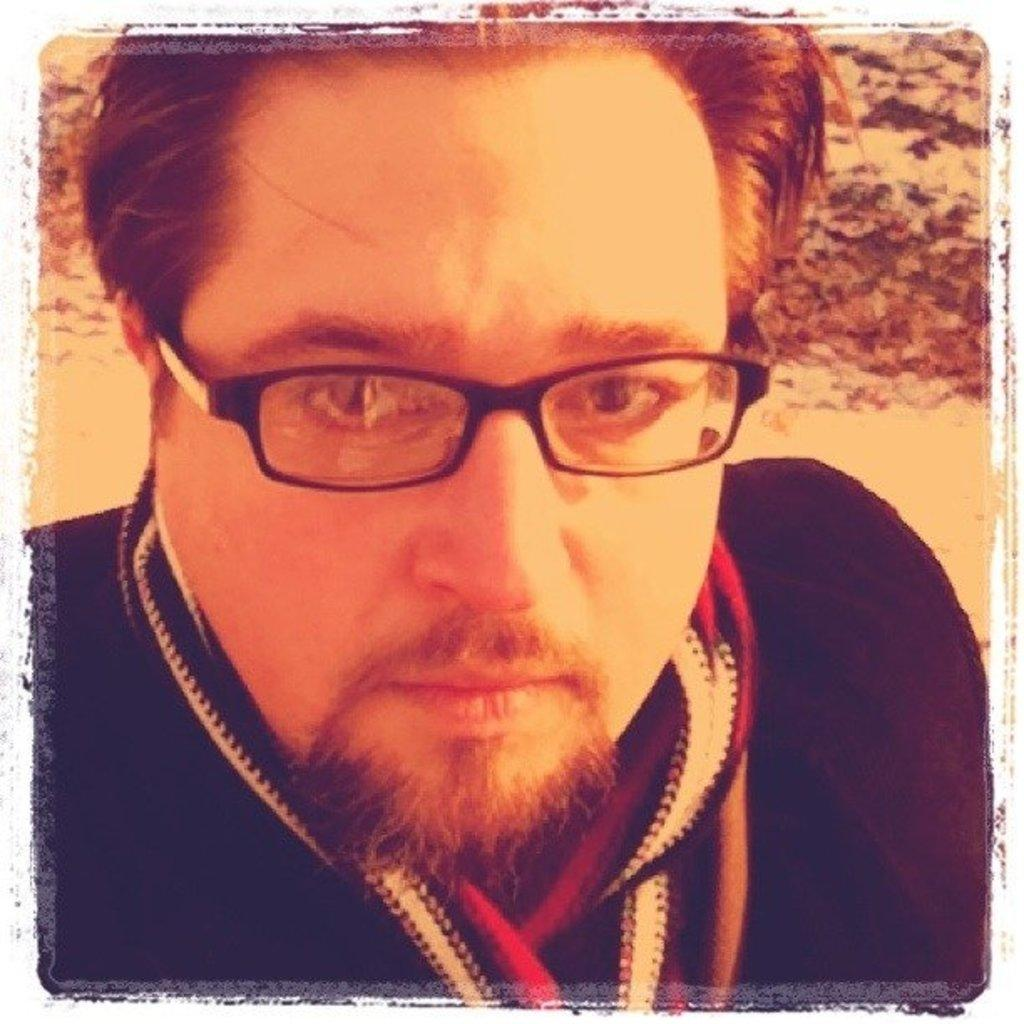What is present in the image? There is a man in the image. Can you describe the man's appearance? The man is wearing spectacles. What type of tub can be seen in the image? There is no tub present in the image. What role does the man's mother play in the image? The provided facts do not mention the man's mother, so we cannot determine her role in the image. 